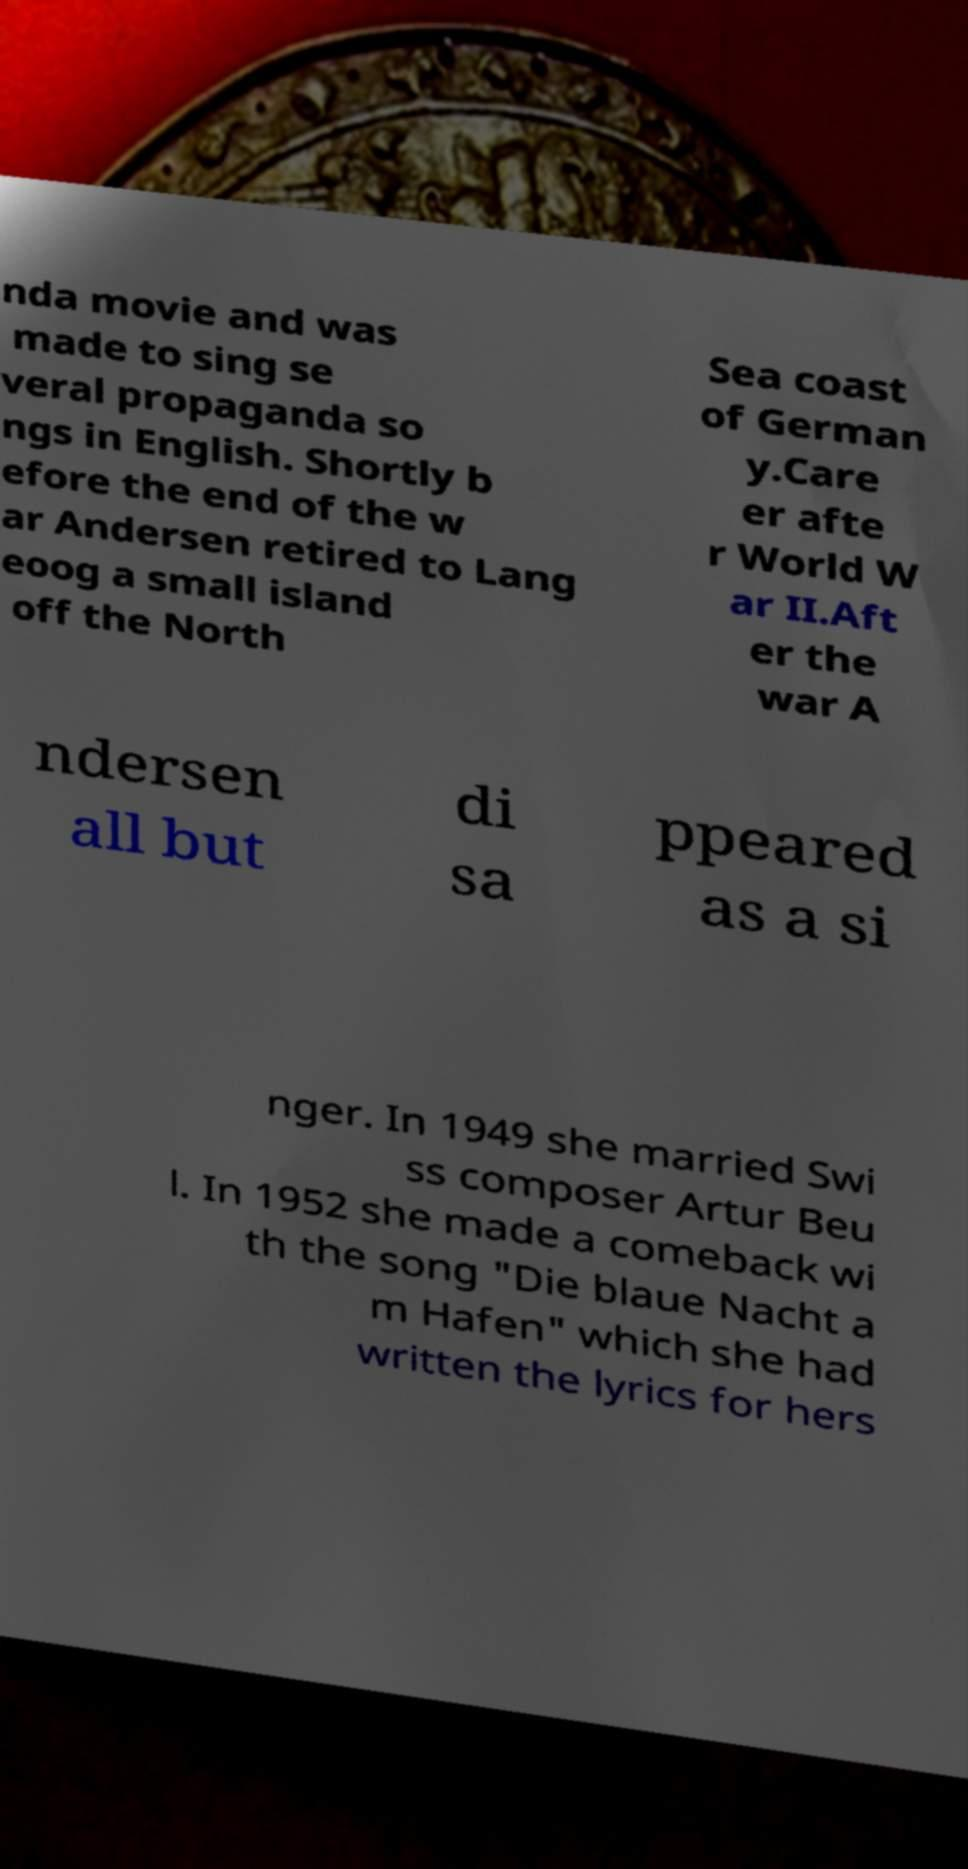For documentation purposes, I need the text within this image transcribed. Could you provide that? nda movie and was made to sing se veral propaganda so ngs in English. Shortly b efore the end of the w ar Andersen retired to Lang eoog a small island off the North Sea coast of German y.Care er afte r World W ar II.Aft er the war A ndersen all but di sa ppeared as a si nger. In 1949 she married Swi ss composer Artur Beu l. In 1952 she made a comeback wi th the song "Die blaue Nacht a m Hafen" which she had written the lyrics for hers 